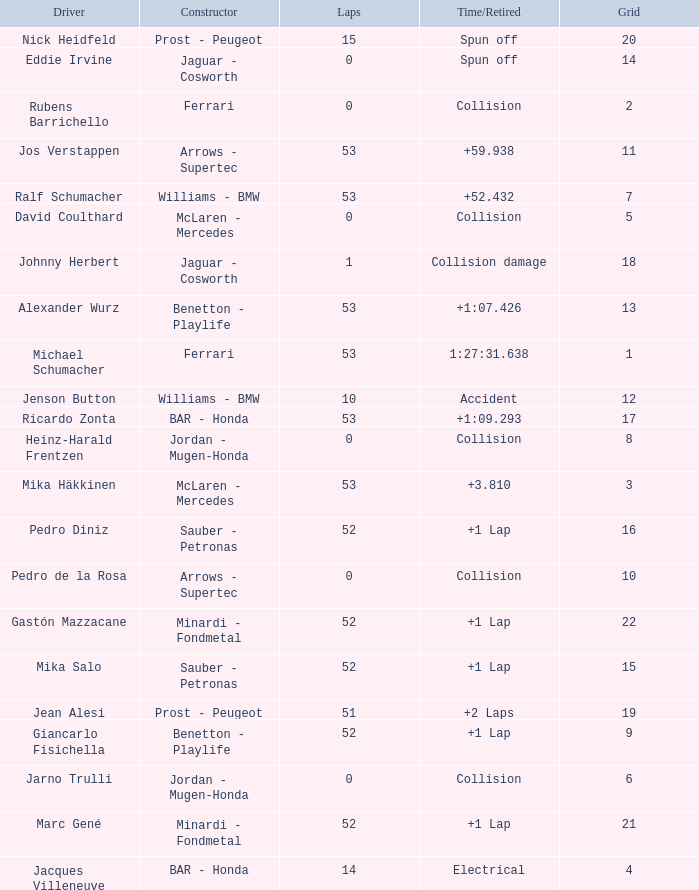What is the average Laps for a grid smaller than 17, and a Constructor of williams - bmw, driven by jenson button? 10.0. 